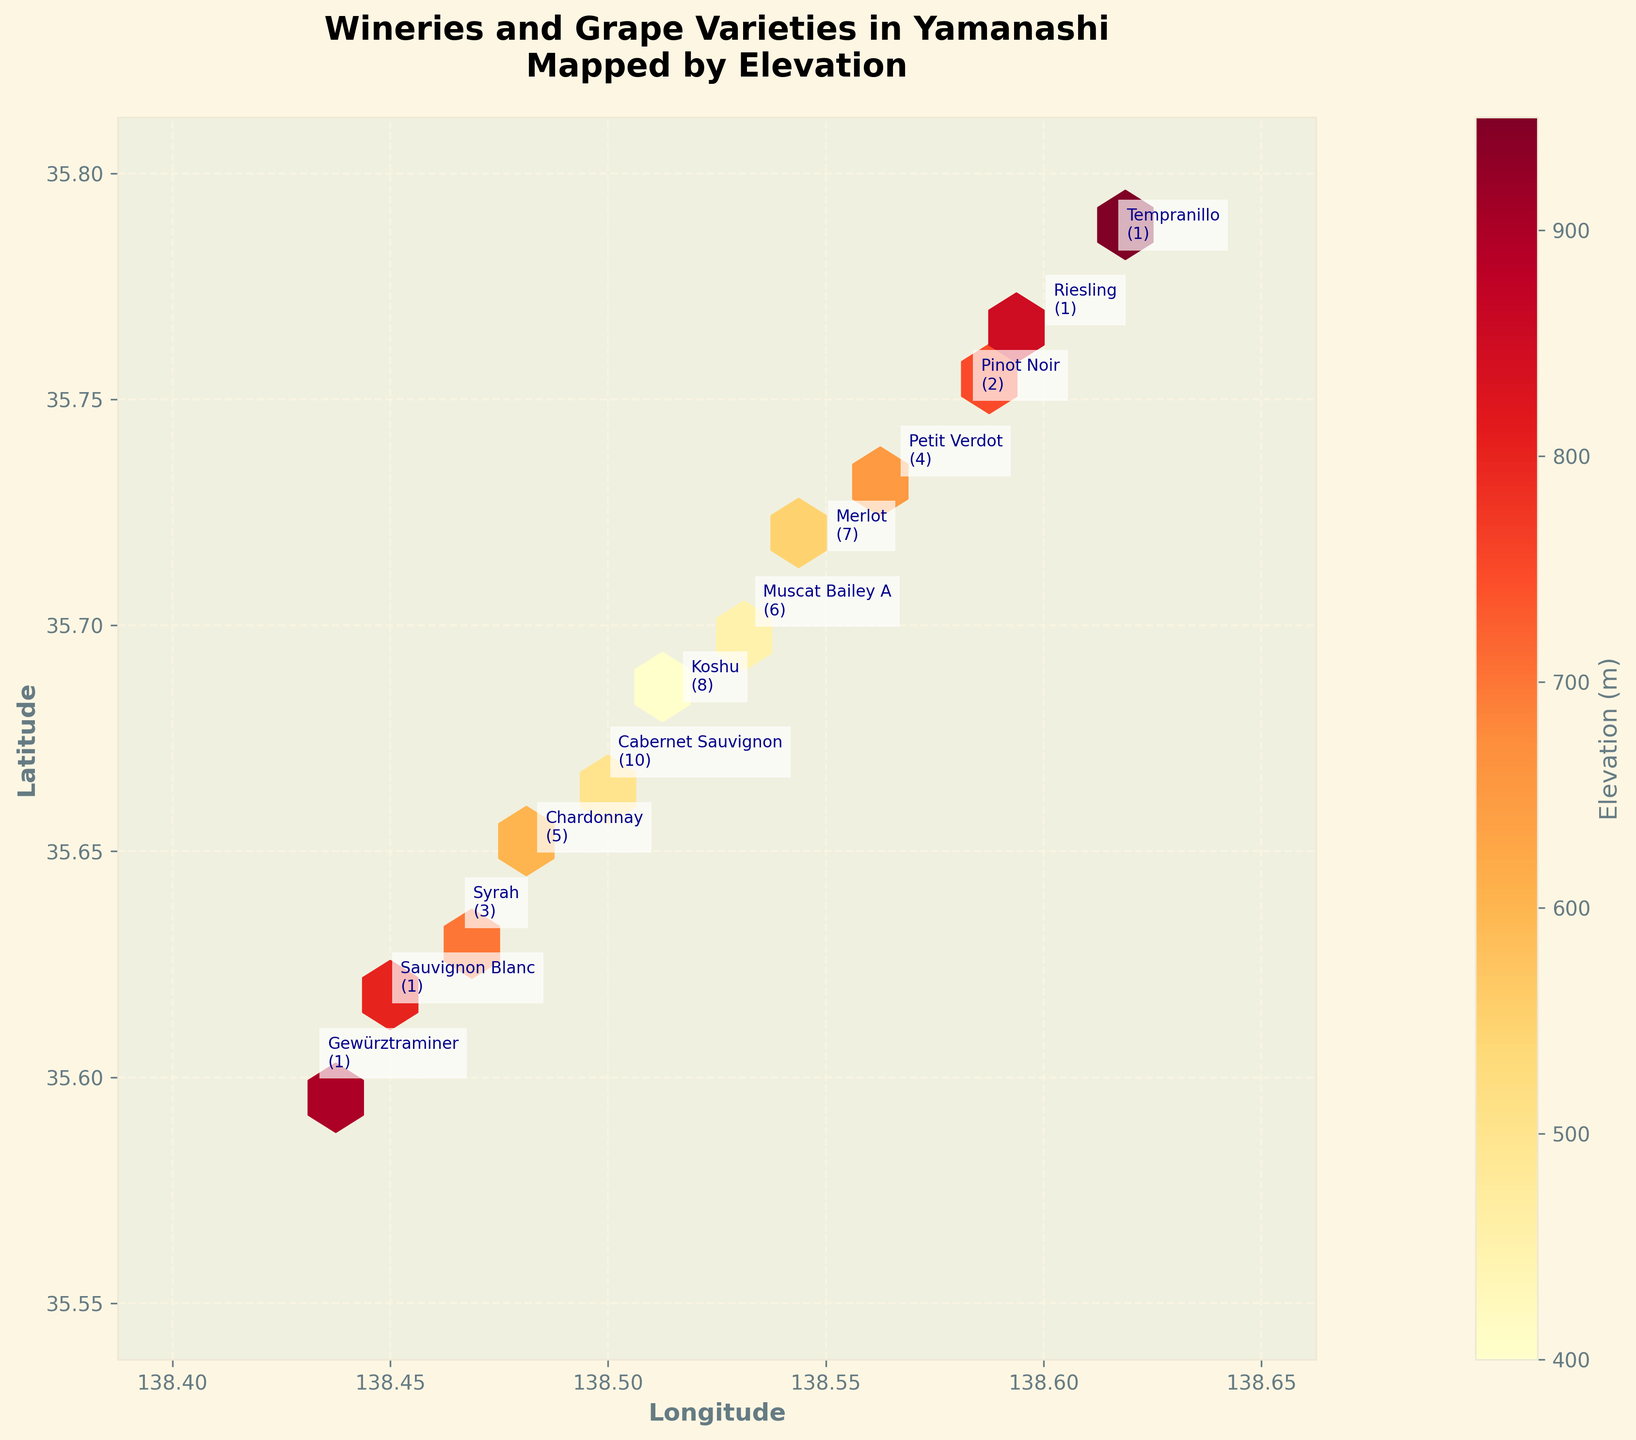What is the title of the hexbin plot? The title is usually displayed at the top of the plot. It shows both the general context and what specific data is presented.
Answer: Wineries and Grape Varieties in Yamanashi Mapped by Elevation Which axis represents Longitude? The axis labels, usually at the bottom or side of the plot, provide this information.
Answer: The horizontal axis (x-axis) What is the color indicating in the hexbin plot? The color bar on the side of the plot indicates what the colors represent. Reading the label on the color bar will provide the answer.
Answer: Elevation (m) How many grape varieties are listed in the plot annotations? Counting each annotation for different grape varieties will provide the answer. Count the number of different grape varieties mentioned in annotations.
Answer: 12 What is the latitude and longitude of the highest elevation winery? Find the hexbin with the highest color intensity on the color bar to locate the highest elevation winery. Check annotations around that hexbin for precise coordinates.
Answer: Latitude: 35.7833, Longitude: 138.6167 Which grape variety is associated with the lowest elevation? Find the hexbin with the lightest color according to the color bar, locate the annotation, and read the grape variety associated with that location.
Answer: Koshu What's the average elevation of wineries producing Sauvignon Blanc and Riesling? Locate the annotations for Sauvignon Blanc and Riesling, note their elevations, then calculate their average. Sauvignon Blanc has an elevation of 800m and Riesling has an elevation of 850m. The average is (800 + 850) / 2.
Answer: 825m Which grape varieties are found at an elevation greater than 700m? Check the annotations on the hexbins where elevation colors match the higher end of the color bar, particularly above 700m. List the grape varieties mentioned in those annotations.
Answer: Pinot Noir, Sauvignon Blanc, Riesling, Gewürztraminer, Tempranillo How many wineries are annotated in the plot? Count all the annotations in the plot to determine the number of wineries. These numbers, in parentheses next to the grape varieties, indicate the concentration of wineries.
Answer: 12 wineries Which grape variety has the highest concentration of wineries, and what is its elevation? Identify the annotation with the highest number next to it (Winery Concentration) and note the elevation associated with that grape variety. Koshu has the highest Winery Concentration at 8 and its elevation is 400m.
Answer: Koshu, 400m 